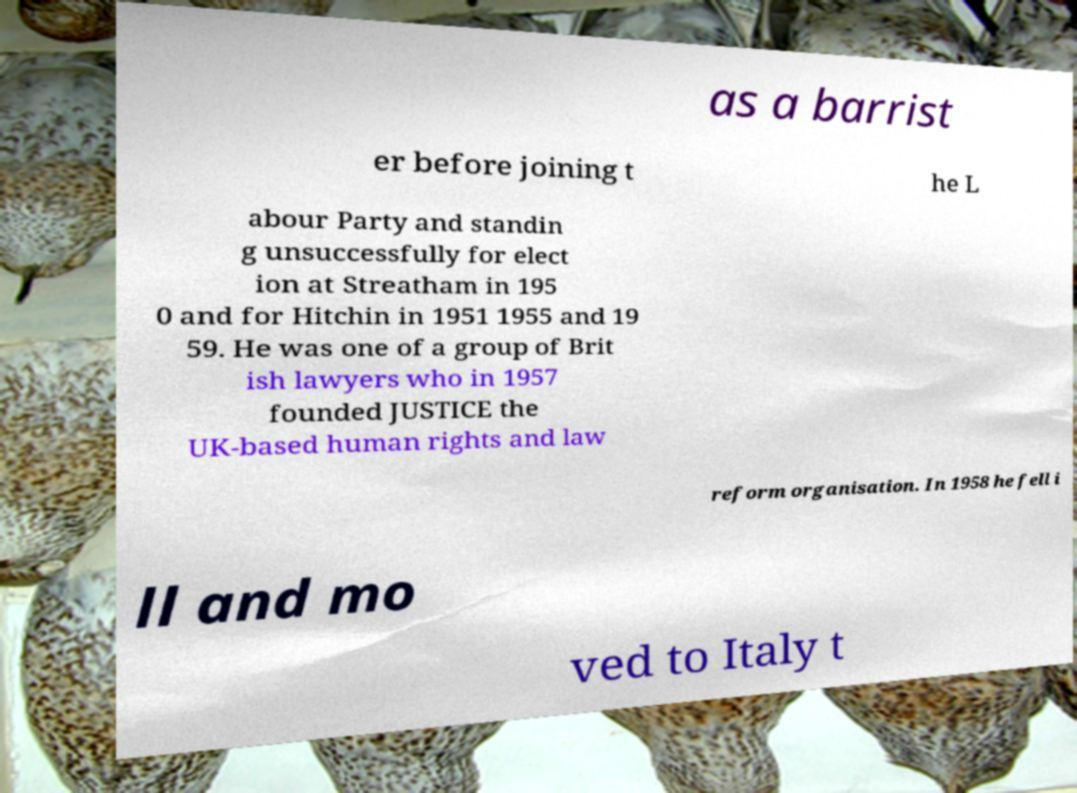Could you assist in decoding the text presented in this image and type it out clearly? as a barrist er before joining t he L abour Party and standin g unsuccessfully for elect ion at Streatham in 195 0 and for Hitchin in 1951 1955 and 19 59. He was one of a group of Brit ish lawyers who in 1957 founded JUSTICE the UK-based human rights and law reform organisation. In 1958 he fell i ll and mo ved to Italy t 